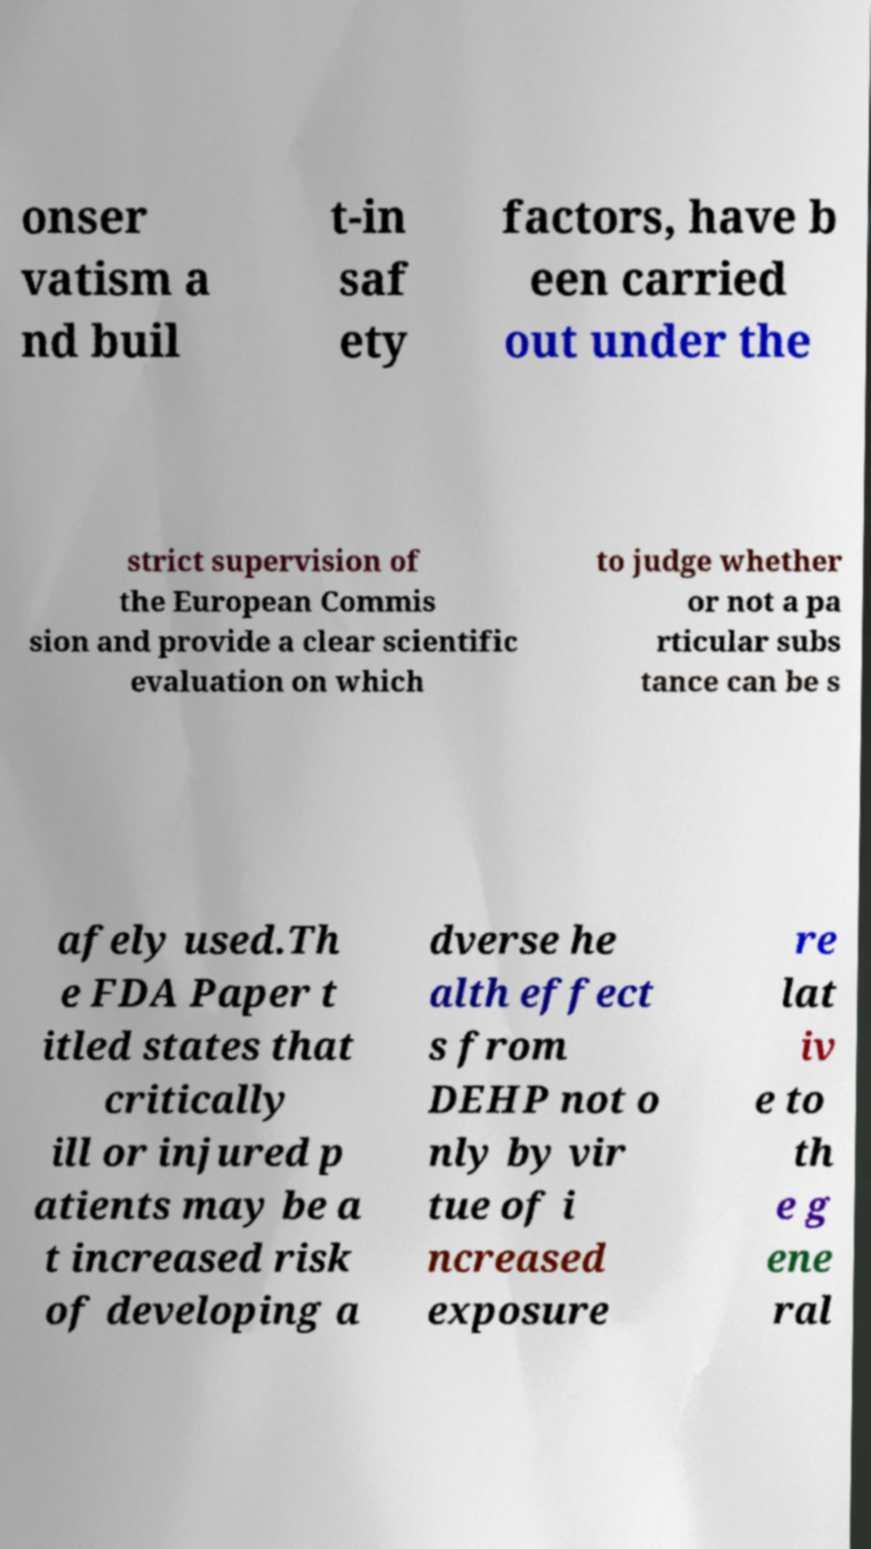Could you assist in decoding the text presented in this image and type it out clearly? onser vatism a nd buil t-in saf ety factors, have b een carried out under the strict supervision of the European Commis sion and provide a clear scientific evaluation on which to judge whether or not a pa rticular subs tance can be s afely used.Th e FDA Paper t itled states that critically ill or injured p atients may be a t increased risk of developing a dverse he alth effect s from DEHP not o nly by vir tue of i ncreased exposure re lat iv e to th e g ene ral 